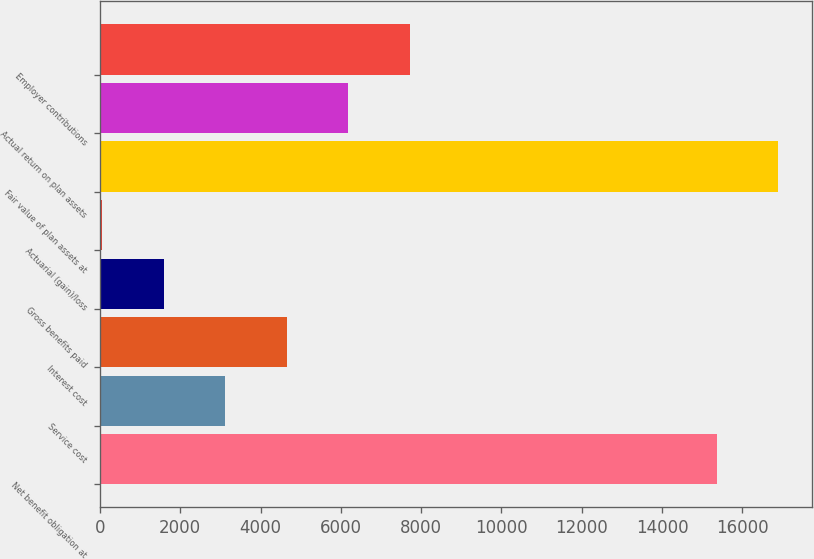Convert chart to OTSL. <chart><loc_0><loc_0><loc_500><loc_500><bar_chart><fcel>Net benefit obligation at<fcel>Service cost<fcel>Interest cost<fcel>Gross benefits paid<fcel>Actuarial (gain)/loss<fcel>Fair value of plan assets at<fcel>Actual return on plan assets<fcel>Employer contributions<nl><fcel>15363<fcel>3118<fcel>4650<fcel>1586<fcel>54<fcel>16895<fcel>6182<fcel>7714<nl></chart> 